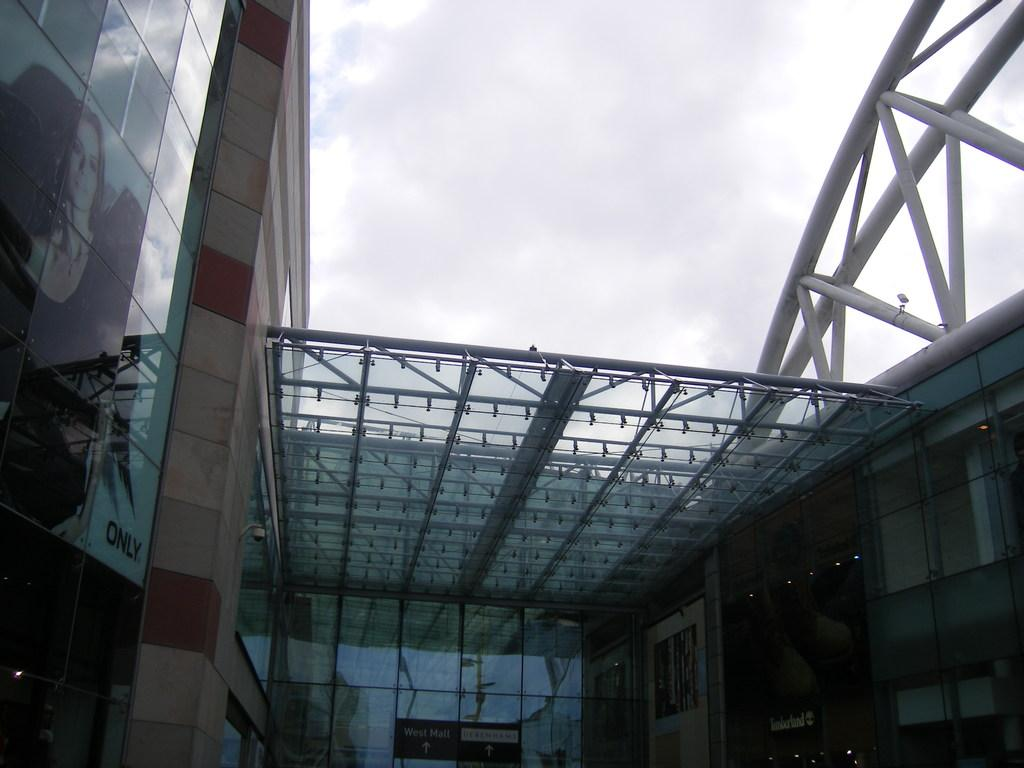What can be seen on the right side of the image? There are buildings on the right side of the image. What can be seen on the left side of the image? There are buildings on the left side of the image. What is located on the left side of the image besides the buildings? There is a poster on the left side of the image. What is in the center of the image? There is a roof in the center of the image. How many cats are sitting on the roof in the image? There are no cats present in the image; it only shows buildings, a poster, and a roof. 